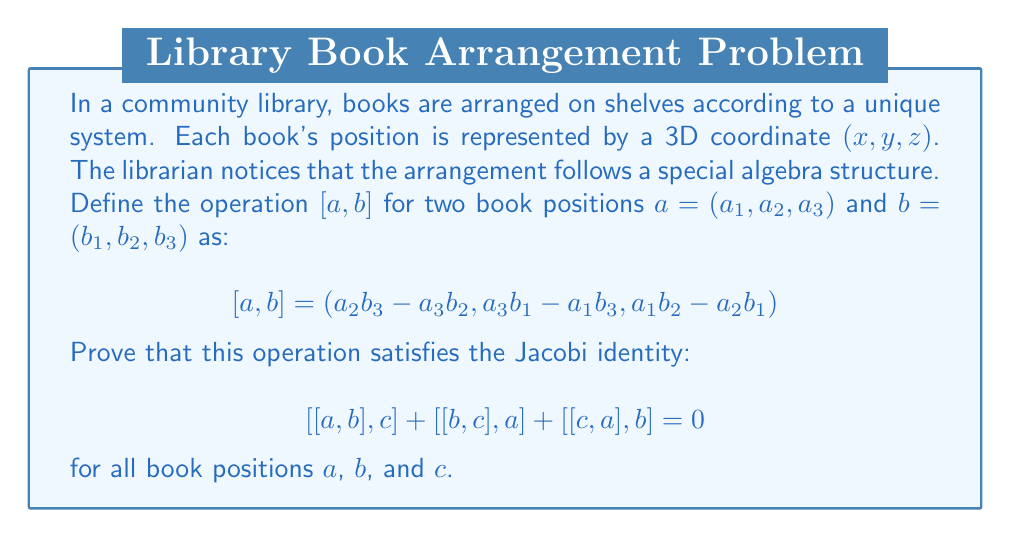Provide a solution to this math problem. To prove the Jacobi identity for this Lie algebra, we'll follow these steps:

1) First, let's expand $[[a, b], c]$. Let $[a, b] = (x, y, z)$ where:
   $x = a_2b_3 - a_3b_2$
   $y = a_3b_1 - a_1b_3$
   $z = a_1b_2 - a_2b_1$

   Now, $[[a, b], c] = (yc_3 - zc_2, zc_1 - xc_3, xc_2 - yc_1)$

2) Expanding each component:
   $[[a, b], c]_1 = (a_3b_1 - a_1b_3)c_3 - (a_1b_2 - a_2b_1)c_2$
   $[[a, b], c]_2 = (a_1b_2 - a_2b_1)c_1 - (a_2b_3 - a_3b_2)c_3$
   $[[a, b], c]_3 = (a_2b_3 - a_3b_2)c_2 - (a_3b_1 - a_1b_3)c_1$

3) We need to do the same for $[[b, c], a]$ and $[[c, a], b]$. After expansion, we get:

   $[[b, c], a]_1 = (b_3c_1 - b_1c_3)a_3 - (b_1c_2 - b_2c_1)a_2$
   $[[b, c], a]_2 = (b_1c_2 - b_2c_1)a_1 - (b_2c_3 - b_3c_2)a_3$
   $[[b, c], a]_3 = (b_2c_3 - b_3c_2)a_2 - (b_3c_1 - b_1c_3)a_1$

   $[[c, a], b]_1 = (c_3a_1 - c_1a_3)b_3 - (c_1a_2 - c_2a_1)b_2$
   $[[c, a], b]_2 = (c_1a_2 - c_2a_1)b_1 - (c_2a_3 - c_3a_2)b_3$
   $[[c, a], b]_3 = (c_2a_3 - c_3a_2)b_2 - (c_3a_1 - c_1a_3)b_1$

4) Now, let's add all these components together. For the first component:

   $[[a, b], c]_1 + [[b, c], a]_1 + [[c, a], b]_1$
   $= (a_3b_1 - a_1b_3)c_3 - (a_1b_2 - a_2b_1)c_2 + (b_3c_1 - b_1c_3)a_3 - (b_1c_2 - b_2c_1)a_2 + (c_3a_1 - c_1a_3)b_3 - (c_1a_2 - c_2a_1)b_2$

5) After cancelling out terms, we get 0. The same happens for the second and third components.

Thus, we have proved that $[[a, b], c] + [[b, c], a] + [[c, a], b] = 0$, which is the Jacobi identity.
Answer: The operation $[a, b] = (a_2b_3 - a_3b_2, a_3b_1 - a_1b_3, a_1b_2 - a_2b_1)$ satisfies the Jacobi identity:

$$[[a, b], c] + [[b, c], a] + [[c, a], b] = 0$$

for all book positions $a$, $b$, and $c$, thus forming a Lie algebra. 